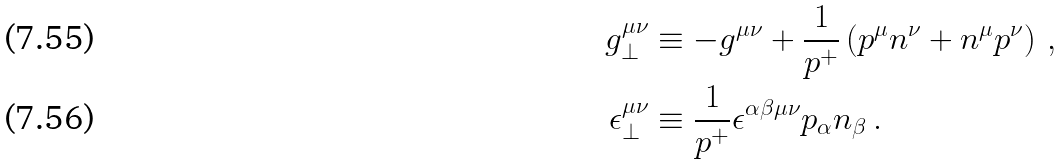Convert formula to latex. <formula><loc_0><loc_0><loc_500><loc_500>g _ { \perp } ^ { \mu \nu } & \equiv - g ^ { \mu \nu } + \frac { 1 } { p ^ { + } } \left ( p ^ { \mu } n ^ { \nu } + n ^ { \mu } p ^ { \nu } \right ) \, , \\ \epsilon _ { \perp } ^ { \mu \nu } & \equiv \frac { 1 } { p ^ { + } } \epsilon ^ { \alpha \beta \mu \nu } p _ { \alpha } n _ { \beta } \, .</formula> 